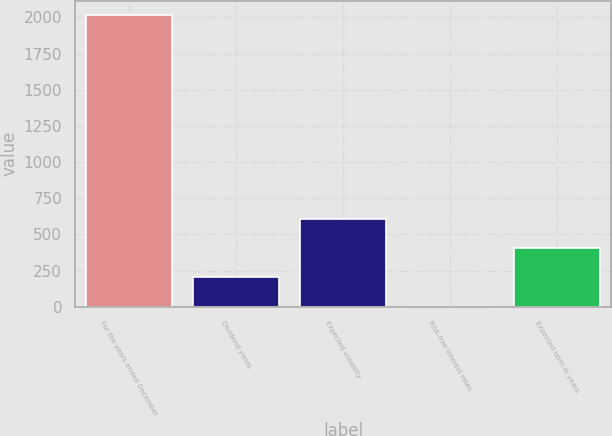<chart> <loc_0><loc_0><loc_500><loc_500><bar_chart><fcel>For the years ended December<fcel>Dividend yields<fcel>Expected volatility<fcel>Risk-free interest rates<fcel>Expected term in years<nl><fcel>2016<fcel>202.95<fcel>605.85<fcel>1.5<fcel>404.4<nl></chart> 